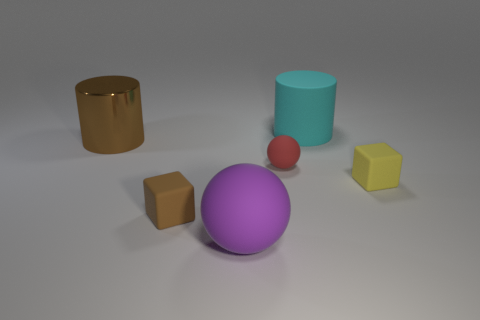What color is the sphere that is in front of the matte ball that is on the right side of the purple ball?
Offer a very short reply. Purple. What is the material of the large brown thing that is the same shape as the cyan matte object?
Offer a very short reply. Metal. How many metallic things are small brown spheres or tiny spheres?
Give a very brief answer. 0. Is the large cylinder on the right side of the purple thing made of the same material as the big cylinder that is in front of the large cyan object?
Provide a succinct answer. No. Are there any big cylinders?
Offer a very short reply. Yes. There is a tiny object that is left of the red object; is it the same shape as the tiny yellow rubber thing that is behind the big purple matte thing?
Offer a very short reply. Yes. Is there a cyan thing that has the same material as the brown cube?
Keep it short and to the point. Yes. Is the block that is right of the small brown cube made of the same material as the brown cylinder?
Make the answer very short. No. Is the number of brown shiny objects that are behind the brown cube greater than the number of big cylinders that are on the right side of the tiny yellow block?
Your response must be concise. Yes. There is a rubber cylinder that is the same size as the purple object; what color is it?
Provide a short and direct response. Cyan. 